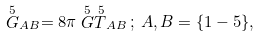<formula> <loc_0><loc_0><loc_500><loc_500>\stackrel { 5 } { G } _ { A B } = 8 \pi \stackrel { 5 } { G } \stackrel { 5 } { T } _ { A B } \, ; \, A , B = \{ 1 - 5 \} ,</formula> 